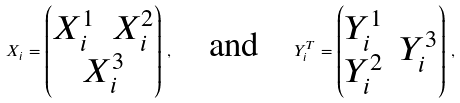<formula> <loc_0><loc_0><loc_500><loc_500>X _ { i } = \left ( \begin{matrix} \begin{matrix} X _ { i } ^ { 1 } & X _ { i } ^ { 2 } \end{matrix} \\ X _ { i } ^ { 3 } \end{matrix} \right ) \, , \quad \text {and} \quad Y _ { i } ^ { T } = \left ( \begin{matrix} \begin{matrix} Y _ { i } ^ { 1 } \\ Y _ { i } ^ { 2 } \end{matrix} & Y _ { i } ^ { 3 } \end{matrix} \right ) \, ,</formula> 